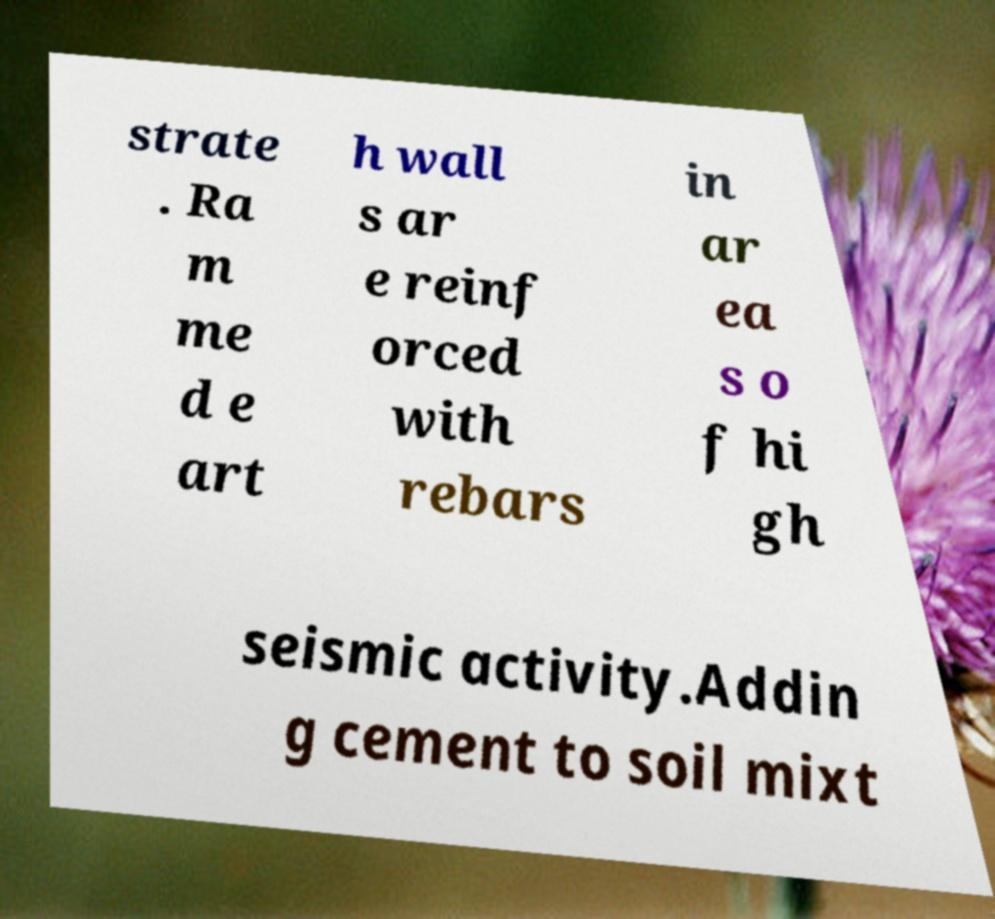Could you extract and type out the text from this image? strate . Ra m me d e art h wall s ar e reinf orced with rebars in ar ea s o f hi gh seismic activity.Addin g cement to soil mixt 